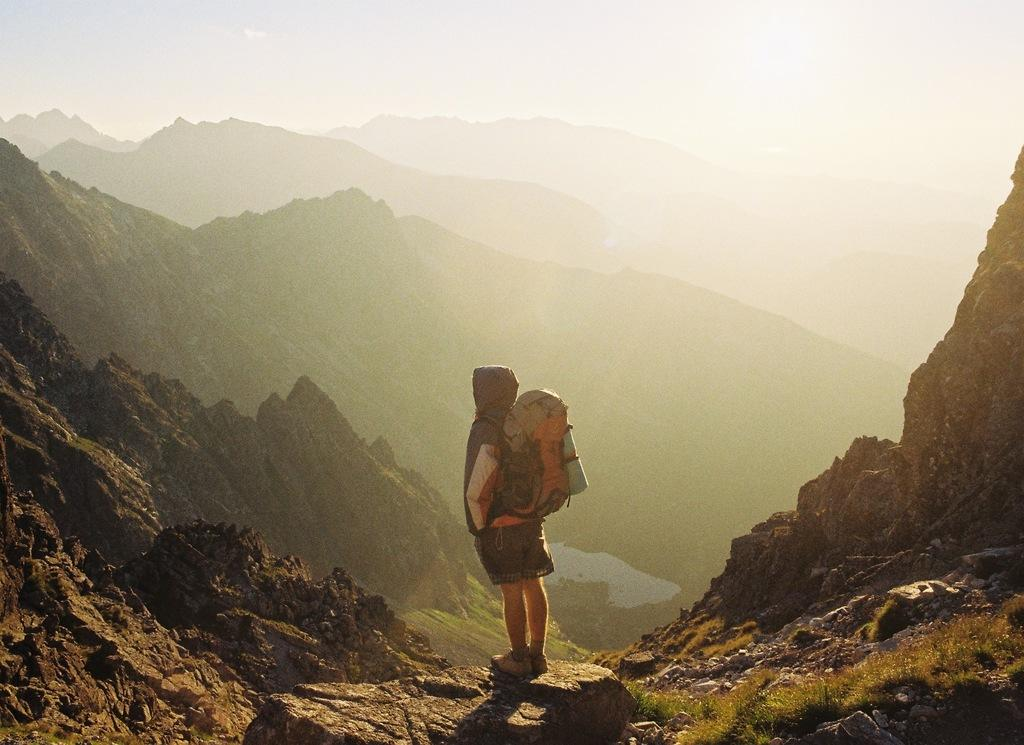What is the main subject of the image? There is a person in the image. What is the person wearing? The person is wearing a backpack. Where is the person standing? The person is standing on a rock. What type of landscape can be seen in the image? Hills are visible in the image, and grass is present on the ground. What atmospheric condition is present in the image? There is fog in the image. What is the health status of the person's son in the image? There is no mention of a son or any health status in the image. 